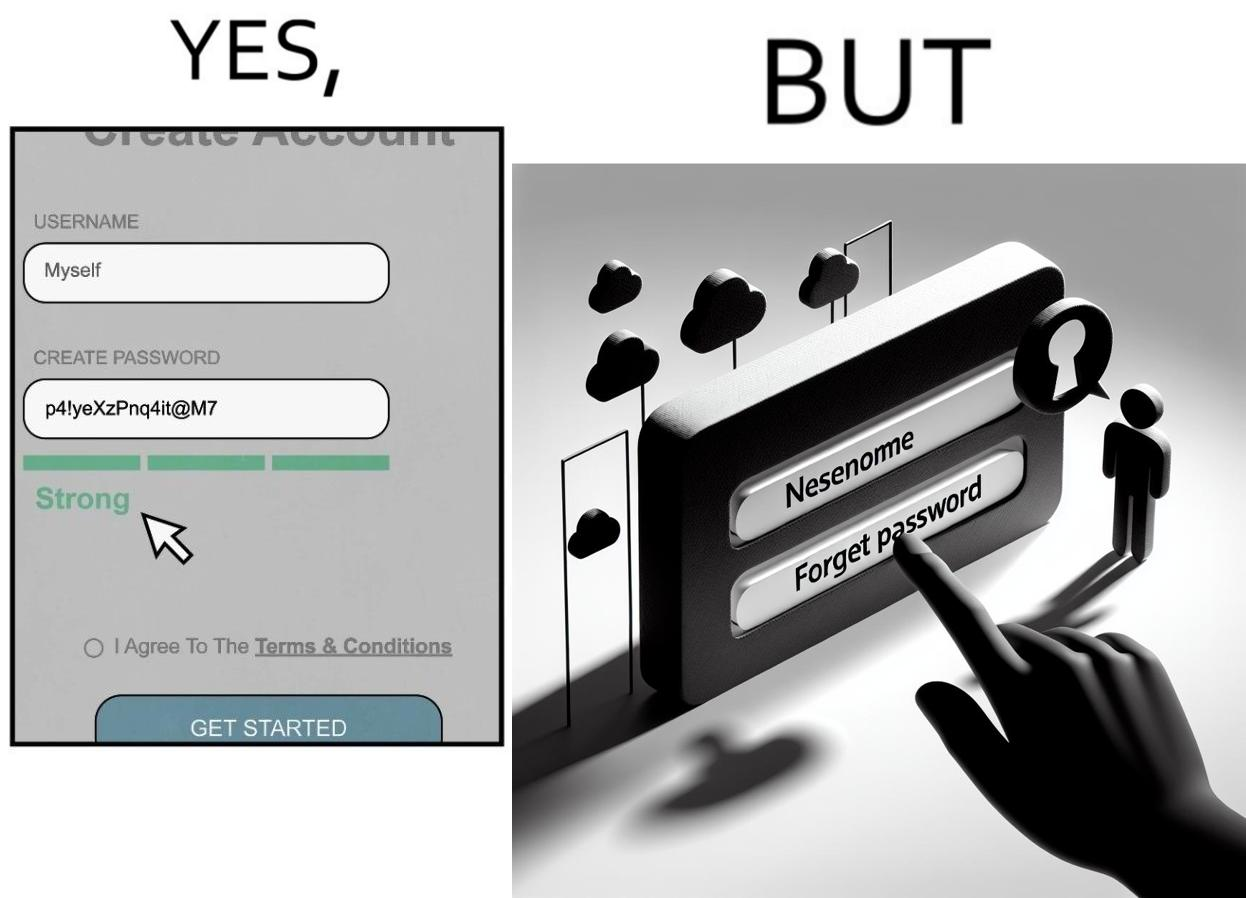Describe the satirical element in this image. The image is ironic, because people set such a strong passwords for their accounts that they even forget the password and need to reset them 